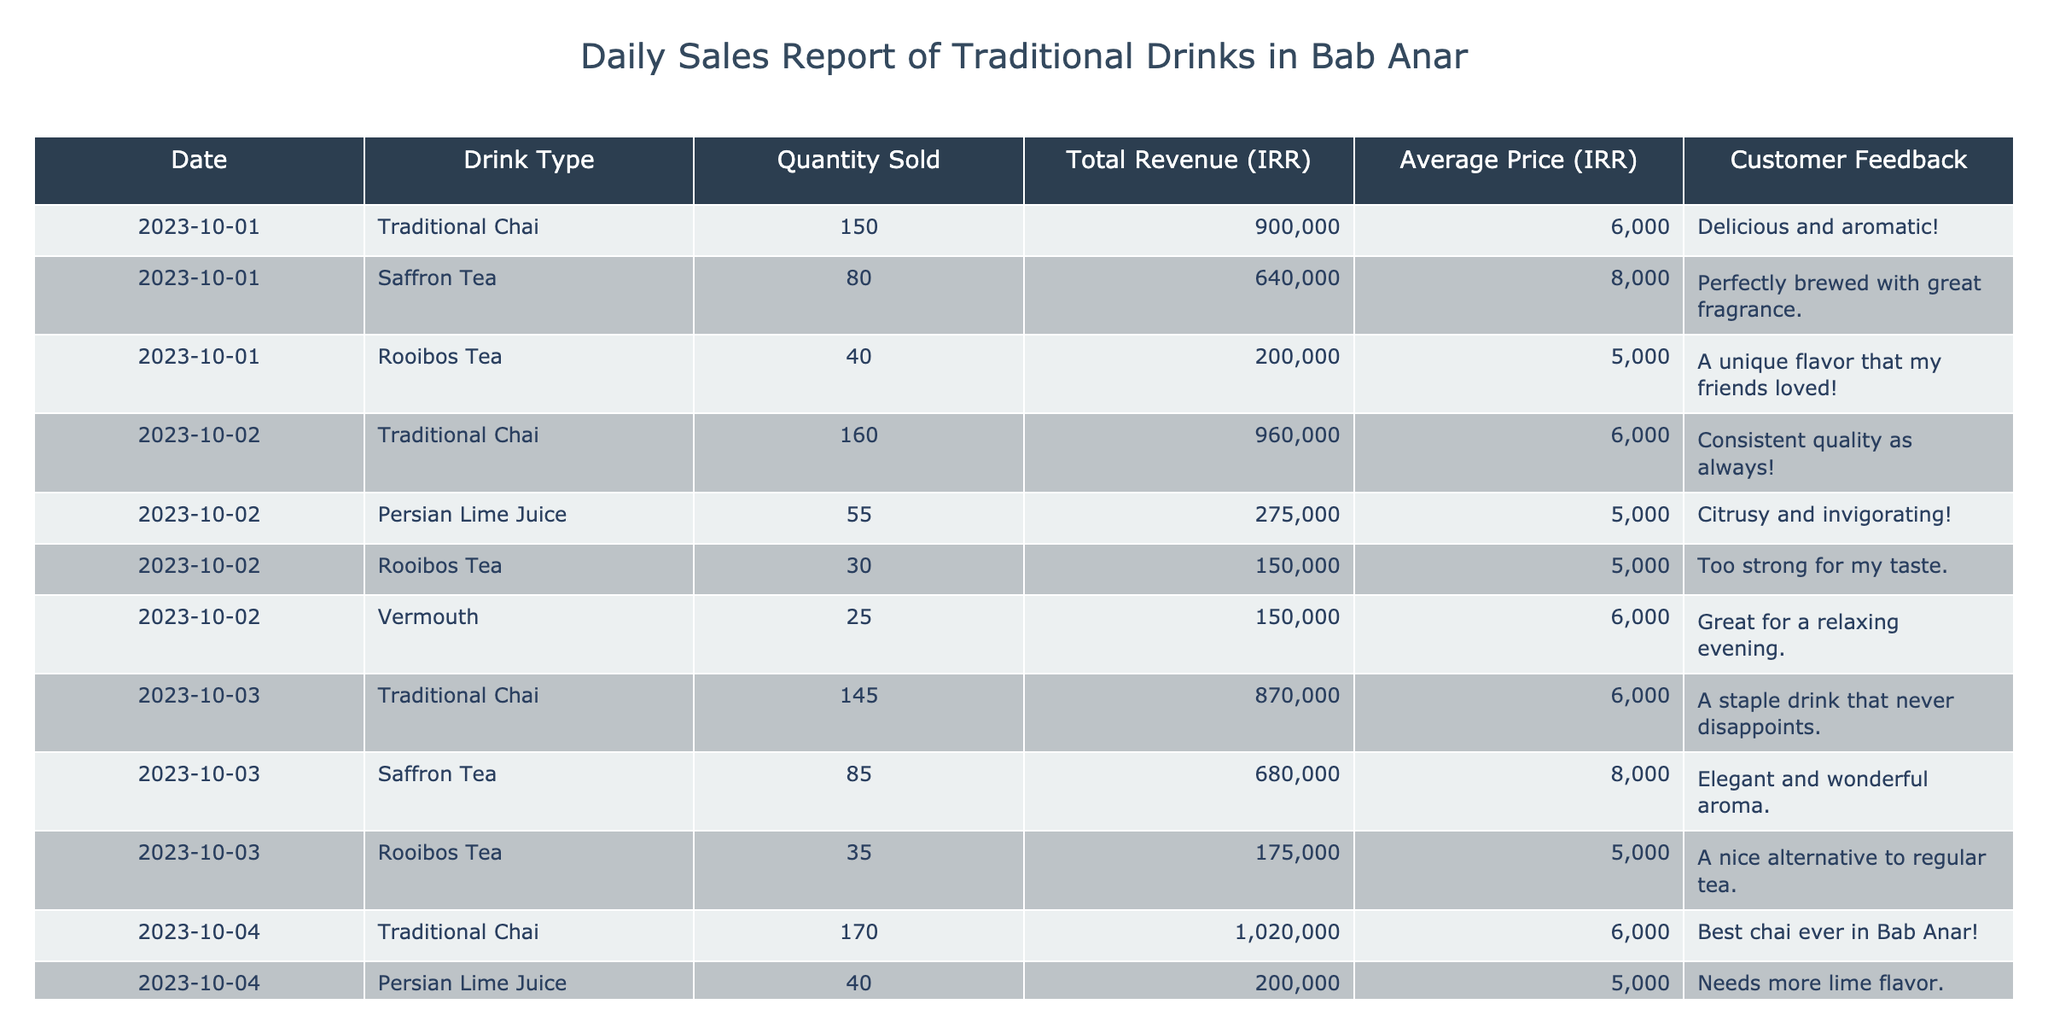What was the total revenue generated from Traditional Chai sales on October 1st? The table shows that 150 cups of Traditional Chai were sold on October 1st, generating a total revenue of 900,000 IRR.
Answer: 900,000 IRR What is the average price of Saffron Tea sold over the recorded days? The average price for Saffron Tea is consistently listed as 8,000 IRR across the recorded days in the table. Since the price does not change, the average remains 8,000 IRR.
Answer: 8,000 IRR How many cups of Rooibos Tea were sold on October 2nd? According to the table, 30 cups of Rooibos Tea were sold on October 2nd.
Answer: 30 cups What drink type generated the highest total revenue on October 4th? On October 4th, Traditional Chai sold 170 cups for a total revenue of 1,020,000 IRR, which is more than any other drink on that day.
Answer: Traditional Chai What was the average quantity sold for Persian Lime Juice over all days? Persian Lime Juice was sold 55 cups on October 2nd and 40 cups on October 4th, totaling 95 cups. To find the average, divide by the number of days (2), resulting in 95/2 = 47.5, approximated to 48.
Answer: 48 cups Did any drink receive negative feedback? Based on the feedback for each drink listed in the table, all comments are positive, indicating no negative feedback.
Answer: No Which drink type had the lowest revenue on October 3rd? On October 3rd, Rooibos Tea generated 175,000 IRR, which is the lowest revenue among the drinks sold on that day.
Answer: Rooibos Tea What is the total quantity sold for each drink type across all days? Summing up the quantities: Traditional Chai = 625, Saffron Tea = 258, Rooibos Tea = 140, Persian Lime Juice = 95, Vermouth = 25. Traditional Chai was sold in the highest quantity among all drinks.
Answer: 625, 258, 140, 95, 25 Between October 1st and October 4th, which day had the highest sales figure and for which drink? On October 4th, Traditional Chai had the highest sales figure, with a total revenue of 1,020,000 IRR, surpassing all other sales figures.
Answer: October 4th, Traditional Chai Is the average price of Rooibos Tea the same across all days? The average price of Rooibos Tea is listed as 5,000 IRR for all days it was sold, confirming it remains consistent.
Answer: Yes 